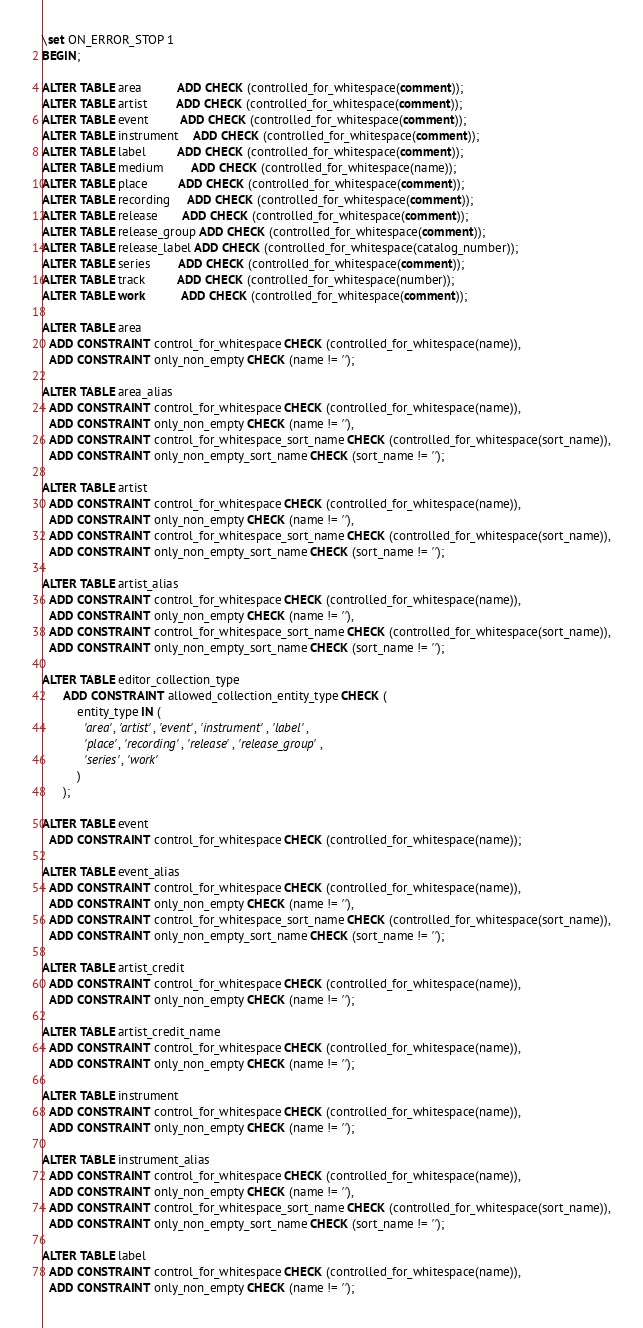Convert code to text. <code><loc_0><loc_0><loc_500><loc_500><_SQL_>\set ON_ERROR_STOP 1
BEGIN;

ALTER TABLE area          ADD CHECK (controlled_for_whitespace(comment));
ALTER TABLE artist        ADD CHECK (controlled_for_whitespace(comment));
ALTER TABLE event         ADD CHECK (controlled_for_whitespace(comment));
ALTER TABLE instrument    ADD CHECK (controlled_for_whitespace(comment));
ALTER TABLE label         ADD CHECK (controlled_for_whitespace(comment));
ALTER TABLE medium        ADD CHECK (controlled_for_whitespace(name));
ALTER TABLE place         ADD CHECK (controlled_for_whitespace(comment));
ALTER TABLE recording     ADD CHECK (controlled_for_whitespace(comment));
ALTER TABLE release       ADD CHECK (controlled_for_whitespace(comment));
ALTER TABLE release_group ADD CHECK (controlled_for_whitespace(comment));
ALTER TABLE release_label ADD CHECK (controlled_for_whitespace(catalog_number));
ALTER TABLE series        ADD CHECK (controlled_for_whitespace(comment));
ALTER TABLE track         ADD CHECK (controlled_for_whitespace(number));
ALTER TABLE work          ADD CHECK (controlled_for_whitespace(comment));

ALTER TABLE area
  ADD CONSTRAINT control_for_whitespace CHECK (controlled_for_whitespace(name)),
  ADD CONSTRAINT only_non_empty CHECK (name != '');

ALTER TABLE area_alias
  ADD CONSTRAINT control_for_whitespace CHECK (controlled_for_whitespace(name)),
  ADD CONSTRAINT only_non_empty CHECK (name != ''),
  ADD CONSTRAINT control_for_whitespace_sort_name CHECK (controlled_for_whitespace(sort_name)),
  ADD CONSTRAINT only_non_empty_sort_name CHECK (sort_name != '');

ALTER TABLE artist
  ADD CONSTRAINT control_for_whitespace CHECK (controlled_for_whitespace(name)),
  ADD CONSTRAINT only_non_empty CHECK (name != ''),
  ADD CONSTRAINT control_for_whitespace_sort_name CHECK (controlled_for_whitespace(sort_name)),
  ADD CONSTRAINT only_non_empty_sort_name CHECK (sort_name != '');

ALTER TABLE artist_alias
  ADD CONSTRAINT control_for_whitespace CHECK (controlled_for_whitespace(name)),
  ADD CONSTRAINT only_non_empty CHECK (name != ''),
  ADD CONSTRAINT control_for_whitespace_sort_name CHECK (controlled_for_whitespace(sort_name)),
  ADD CONSTRAINT only_non_empty_sort_name CHECK (sort_name != '');

ALTER TABLE editor_collection_type
      ADD CONSTRAINT allowed_collection_entity_type CHECK (
          entity_type IN (
            'area', 'artist', 'event', 'instrument', 'label',
            'place', 'recording', 'release', 'release_group',
            'series', 'work'
          )
      );

ALTER TABLE event
  ADD CONSTRAINT control_for_whitespace CHECK (controlled_for_whitespace(name));

ALTER TABLE event_alias
  ADD CONSTRAINT control_for_whitespace CHECK (controlled_for_whitespace(name)),
  ADD CONSTRAINT only_non_empty CHECK (name != ''),
  ADD CONSTRAINT control_for_whitespace_sort_name CHECK (controlled_for_whitespace(sort_name)),
  ADD CONSTRAINT only_non_empty_sort_name CHECK (sort_name != '');

ALTER TABLE artist_credit
  ADD CONSTRAINT control_for_whitespace CHECK (controlled_for_whitespace(name)),
  ADD CONSTRAINT only_non_empty CHECK (name != '');

ALTER TABLE artist_credit_name
  ADD CONSTRAINT control_for_whitespace CHECK (controlled_for_whitespace(name)),
  ADD CONSTRAINT only_non_empty CHECK (name != '');

ALTER TABLE instrument
  ADD CONSTRAINT control_for_whitespace CHECK (controlled_for_whitespace(name)),
  ADD CONSTRAINT only_non_empty CHECK (name != '');

ALTER TABLE instrument_alias
  ADD CONSTRAINT control_for_whitespace CHECK (controlled_for_whitespace(name)),
  ADD CONSTRAINT only_non_empty CHECK (name != ''),
  ADD CONSTRAINT control_for_whitespace_sort_name CHECK (controlled_for_whitespace(sort_name)),
  ADD CONSTRAINT only_non_empty_sort_name CHECK (sort_name != '');

ALTER TABLE label
  ADD CONSTRAINT control_for_whitespace CHECK (controlled_for_whitespace(name)),
  ADD CONSTRAINT only_non_empty CHECK (name != '');
</code> 